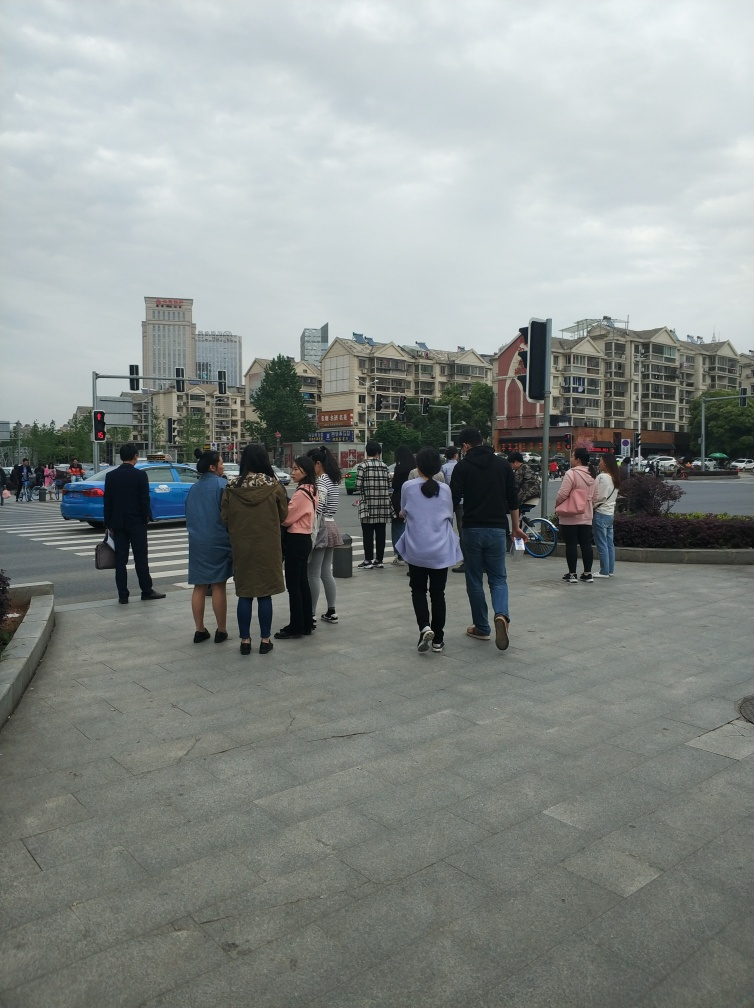What is the mood of the crowd in the image? The mood of the crowd appears casual and typical for urban street life, as people are crossing the street seemingly engaged in their own thoughts or conversations. 